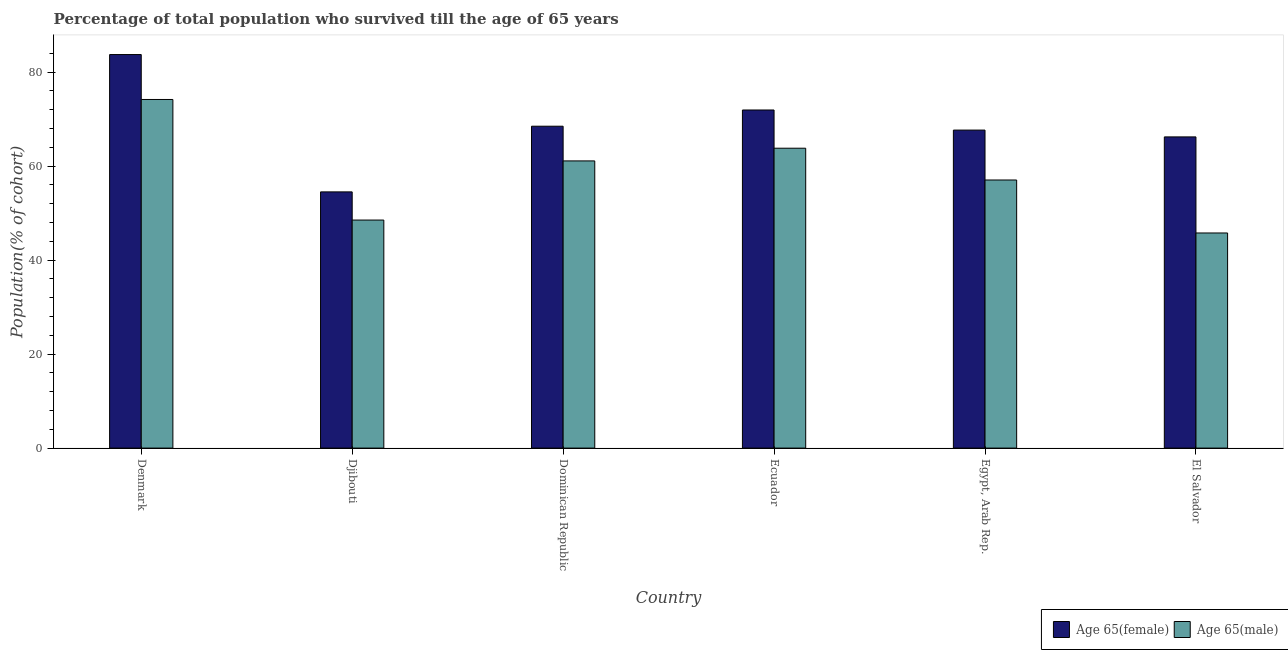Are the number of bars on each tick of the X-axis equal?
Offer a very short reply. Yes. What is the label of the 4th group of bars from the left?
Ensure brevity in your answer.  Ecuador. What is the percentage of male population who survived till age of 65 in Dominican Republic?
Keep it short and to the point. 61.1. Across all countries, what is the maximum percentage of female population who survived till age of 65?
Give a very brief answer. 83.73. Across all countries, what is the minimum percentage of female population who survived till age of 65?
Your answer should be compact. 54.51. In which country was the percentage of female population who survived till age of 65 maximum?
Ensure brevity in your answer.  Denmark. In which country was the percentage of male population who survived till age of 65 minimum?
Your response must be concise. El Salvador. What is the total percentage of female population who survived till age of 65 in the graph?
Make the answer very short. 412.53. What is the difference between the percentage of female population who survived till age of 65 in Denmark and that in Dominican Republic?
Offer a terse response. 15.25. What is the difference between the percentage of male population who survived till age of 65 in Djibouti and the percentage of female population who survived till age of 65 in Egypt, Arab Rep.?
Make the answer very short. -19.14. What is the average percentage of female population who survived till age of 65 per country?
Your answer should be very brief. 68.76. What is the difference between the percentage of male population who survived till age of 65 and percentage of female population who survived till age of 65 in Dominican Republic?
Provide a succinct answer. -7.38. In how many countries, is the percentage of male population who survived till age of 65 greater than 60 %?
Offer a terse response. 3. What is the ratio of the percentage of male population who survived till age of 65 in Dominican Republic to that in Ecuador?
Your answer should be compact. 0.96. Is the percentage of male population who survived till age of 65 in Denmark less than that in Djibouti?
Your response must be concise. No. What is the difference between the highest and the second highest percentage of female population who survived till age of 65?
Make the answer very short. 11.79. What is the difference between the highest and the lowest percentage of male population who survived till age of 65?
Give a very brief answer. 28.4. In how many countries, is the percentage of female population who survived till age of 65 greater than the average percentage of female population who survived till age of 65 taken over all countries?
Your response must be concise. 2. What does the 2nd bar from the left in Ecuador represents?
Your answer should be very brief. Age 65(male). What does the 2nd bar from the right in Denmark represents?
Ensure brevity in your answer.  Age 65(female). How many bars are there?
Offer a terse response. 12. Are all the bars in the graph horizontal?
Ensure brevity in your answer.  No. Are the values on the major ticks of Y-axis written in scientific E-notation?
Make the answer very short. No. Does the graph contain any zero values?
Offer a very short reply. No. Where does the legend appear in the graph?
Provide a short and direct response. Bottom right. How many legend labels are there?
Your answer should be compact. 2. What is the title of the graph?
Ensure brevity in your answer.  Percentage of total population who survived till the age of 65 years. Does "Depositors" appear as one of the legend labels in the graph?
Provide a short and direct response. No. What is the label or title of the X-axis?
Make the answer very short. Country. What is the label or title of the Y-axis?
Provide a succinct answer. Population(% of cohort). What is the Population(% of cohort) in Age 65(female) in Denmark?
Give a very brief answer. 83.73. What is the Population(% of cohort) in Age 65(male) in Denmark?
Your response must be concise. 74.17. What is the Population(% of cohort) of Age 65(female) in Djibouti?
Keep it short and to the point. 54.51. What is the Population(% of cohort) in Age 65(male) in Djibouti?
Provide a short and direct response. 48.52. What is the Population(% of cohort) in Age 65(female) in Dominican Republic?
Provide a succinct answer. 68.48. What is the Population(% of cohort) of Age 65(male) in Dominican Republic?
Offer a very short reply. 61.1. What is the Population(% of cohort) in Age 65(female) in Ecuador?
Give a very brief answer. 71.94. What is the Population(% of cohort) in Age 65(male) in Ecuador?
Provide a succinct answer. 63.81. What is the Population(% of cohort) in Age 65(female) in Egypt, Arab Rep.?
Keep it short and to the point. 67.66. What is the Population(% of cohort) in Age 65(male) in Egypt, Arab Rep.?
Make the answer very short. 57.04. What is the Population(% of cohort) of Age 65(female) in El Salvador?
Offer a very short reply. 66.21. What is the Population(% of cohort) in Age 65(male) in El Salvador?
Your response must be concise. 45.77. Across all countries, what is the maximum Population(% of cohort) in Age 65(female)?
Make the answer very short. 83.73. Across all countries, what is the maximum Population(% of cohort) of Age 65(male)?
Your response must be concise. 74.17. Across all countries, what is the minimum Population(% of cohort) of Age 65(female)?
Give a very brief answer. 54.51. Across all countries, what is the minimum Population(% of cohort) of Age 65(male)?
Ensure brevity in your answer.  45.77. What is the total Population(% of cohort) of Age 65(female) in the graph?
Give a very brief answer. 412.53. What is the total Population(% of cohort) in Age 65(male) in the graph?
Offer a terse response. 350.41. What is the difference between the Population(% of cohort) in Age 65(female) in Denmark and that in Djibouti?
Provide a succinct answer. 29.22. What is the difference between the Population(% of cohort) in Age 65(male) in Denmark and that in Djibouti?
Offer a terse response. 25.65. What is the difference between the Population(% of cohort) in Age 65(female) in Denmark and that in Dominican Republic?
Keep it short and to the point. 15.25. What is the difference between the Population(% of cohort) of Age 65(male) in Denmark and that in Dominican Republic?
Your response must be concise. 13.07. What is the difference between the Population(% of cohort) of Age 65(female) in Denmark and that in Ecuador?
Give a very brief answer. 11.79. What is the difference between the Population(% of cohort) of Age 65(male) in Denmark and that in Ecuador?
Your answer should be compact. 10.37. What is the difference between the Population(% of cohort) in Age 65(female) in Denmark and that in Egypt, Arab Rep.?
Provide a succinct answer. 16.07. What is the difference between the Population(% of cohort) of Age 65(male) in Denmark and that in Egypt, Arab Rep.?
Ensure brevity in your answer.  17.13. What is the difference between the Population(% of cohort) of Age 65(female) in Denmark and that in El Salvador?
Provide a succinct answer. 17.52. What is the difference between the Population(% of cohort) of Age 65(male) in Denmark and that in El Salvador?
Your answer should be very brief. 28.4. What is the difference between the Population(% of cohort) of Age 65(female) in Djibouti and that in Dominican Republic?
Your answer should be very brief. -13.97. What is the difference between the Population(% of cohort) of Age 65(male) in Djibouti and that in Dominican Republic?
Your answer should be very brief. -12.58. What is the difference between the Population(% of cohort) of Age 65(female) in Djibouti and that in Ecuador?
Ensure brevity in your answer.  -17.43. What is the difference between the Population(% of cohort) in Age 65(male) in Djibouti and that in Ecuador?
Offer a terse response. -15.29. What is the difference between the Population(% of cohort) in Age 65(female) in Djibouti and that in Egypt, Arab Rep.?
Give a very brief answer. -13.15. What is the difference between the Population(% of cohort) in Age 65(male) in Djibouti and that in Egypt, Arab Rep.?
Your response must be concise. -8.52. What is the difference between the Population(% of cohort) of Age 65(female) in Djibouti and that in El Salvador?
Offer a very short reply. -11.7. What is the difference between the Population(% of cohort) in Age 65(male) in Djibouti and that in El Salvador?
Provide a short and direct response. 2.75. What is the difference between the Population(% of cohort) in Age 65(female) in Dominican Republic and that in Ecuador?
Offer a very short reply. -3.45. What is the difference between the Population(% of cohort) of Age 65(male) in Dominican Republic and that in Ecuador?
Give a very brief answer. -2.7. What is the difference between the Population(% of cohort) in Age 65(female) in Dominican Republic and that in Egypt, Arab Rep.?
Your answer should be very brief. 0.83. What is the difference between the Population(% of cohort) in Age 65(male) in Dominican Republic and that in Egypt, Arab Rep.?
Ensure brevity in your answer.  4.06. What is the difference between the Population(% of cohort) in Age 65(female) in Dominican Republic and that in El Salvador?
Give a very brief answer. 2.27. What is the difference between the Population(% of cohort) of Age 65(male) in Dominican Republic and that in El Salvador?
Your answer should be very brief. 15.33. What is the difference between the Population(% of cohort) in Age 65(female) in Ecuador and that in Egypt, Arab Rep.?
Your answer should be very brief. 4.28. What is the difference between the Population(% of cohort) in Age 65(male) in Ecuador and that in Egypt, Arab Rep.?
Provide a short and direct response. 6.76. What is the difference between the Population(% of cohort) of Age 65(female) in Ecuador and that in El Salvador?
Your answer should be compact. 5.73. What is the difference between the Population(% of cohort) of Age 65(male) in Ecuador and that in El Salvador?
Offer a terse response. 18.04. What is the difference between the Population(% of cohort) in Age 65(female) in Egypt, Arab Rep. and that in El Salvador?
Provide a succinct answer. 1.45. What is the difference between the Population(% of cohort) in Age 65(male) in Egypt, Arab Rep. and that in El Salvador?
Provide a short and direct response. 11.27. What is the difference between the Population(% of cohort) of Age 65(female) in Denmark and the Population(% of cohort) of Age 65(male) in Djibouti?
Provide a short and direct response. 35.21. What is the difference between the Population(% of cohort) in Age 65(female) in Denmark and the Population(% of cohort) in Age 65(male) in Dominican Republic?
Your answer should be very brief. 22.63. What is the difference between the Population(% of cohort) of Age 65(female) in Denmark and the Population(% of cohort) of Age 65(male) in Ecuador?
Provide a succinct answer. 19.93. What is the difference between the Population(% of cohort) of Age 65(female) in Denmark and the Population(% of cohort) of Age 65(male) in Egypt, Arab Rep.?
Your answer should be compact. 26.69. What is the difference between the Population(% of cohort) in Age 65(female) in Denmark and the Population(% of cohort) in Age 65(male) in El Salvador?
Keep it short and to the point. 37.96. What is the difference between the Population(% of cohort) of Age 65(female) in Djibouti and the Population(% of cohort) of Age 65(male) in Dominican Republic?
Offer a terse response. -6.59. What is the difference between the Population(% of cohort) of Age 65(female) in Djibouti and the Population(% of cohort) of Age 65(male) in Ecuador?
Provide a short and direct response. -9.29. What is the difference between the Population(% of cohort) in Age 65(female) in Djibouti and the Population(% of cohort) in Age 65(male) in Egypt, Arab Rep.?
Make the answer very short. -2.53. What is the difference between the Population(% of cohort) of Age 65(female) in Djibouti and the Population(% of cohort) of Age 65(male) in El Salvador?
Offer a very short reply. 8.74. What is the difference between the Population(% of cohort) in Age 65(female) in Dominican Republic and the Population(% of cohort) in Age 65(male) in Ecuador?
Your response must be concise. 4.68. What is the difference between the Population(% of cohort) of Age 65(female) in Dominican Republic and the Population(% of cohort) of Age 65(male) in Egypt, Arab Rep.?
Give a very brief answer. 11.44. What is the difference between the Population(% of cohort) in Age 65(female) in Dominican Republic and the Population(% of cohort) in Age 65(male) in El Salvador?
Make the answer very short. 22.72. What is the difference between the Population(% of cohort) in Age 65(female) in Ecuador and the Population(% of cohort) in Age 65(male) in Egypt, Arab Rep.?
Provide a succinct answer. 14.89. What is the difference between the Population(% of cohort) of Age 65(female) in Ecuador and the Population(% of cohort) of Age 65(male) in El Salvador?
Keep it short and to the point. 26.17. What is the difference between the Population(% of cohort) in Age 65(female) in Egypt, Arab Rep. and the Population(% of cohort) in Age 65(male) in El Salvador?
Your answer should be compact. 21.89. What is the average Population(% of cohort) of Age 65(female) per country?
Give a very brief answer. 68.76. What is the average Population(% of cohort) in Age 65(male) per country?
Make the answer very short. 58.4. What is the difference between the Population(% of cohort) of Age 65(female) and Population(% of cohort) of Age 65(male) in Denmark?
Provide a short and direct response. 9.56. What is the difference between the Population(% of cohort) in Age 65(female) and Population(% of cohort) in Age 65(male) in Djibouti?
Offer a very short reply. 5.99. What is the difference between the Population(% of cohort) in Age 65(female) and Population(% of cohort) in Age 65(male) in Dominican Republic?
Your answer should be compact. 7.38. What is the difference between the Population(% of cohort) of Age 65(female) and Population(% of cohort) of Age 65(male) in Ecuador?
Offer a terse response. 8.13. What is the difference between the Population(% of cohort) of Age 65(female) and Population(% of cohort) of Age 65(male) in Egypt, Arab Rep.?
Your answer should be very brief. 10.62. What is the difference between the Population(% of cohort) in Age 65(female) and Population(% of cohort) in Age 65(male) in El Salvador?
Make the answer very short. 20.44. What is the ratio of the Population(% of cohort) in Age 65(female) in Denmark to that in Djibouti?
Your answer should be very brief. 1.54. What is the ratio of the Population(% of cohort) of Age 65(male) in Denmark to that in Djibouti?
Your answer should be compact. 1.53. What is the ratio of the Population(% of cohort) in Age 65(female) in Denmark to that in Dominican Republic?
Your answer should be compact. 1.22. What is the ratio of the Population(% of cohort) of Age 65(male) in Denmark to that in Dominican Republic?
Provide a short and direct response. 1.21. What is the ratio of the Population(% of cohort) in Age 65(female) in Denmark to that in Ecuador?
Provide a short and direct response. 1.16. What is the ratio of the Population(% of cohort) of Age 65(male) in Denmark to that in Ecuador?
Your answer should be compact. 1.16. What is the ratio of the Population(% of cohort) in Age 65(female) in Denmark to that in Egypt, Arab Rep.?
Give a very brief answer. 1.24. What is the ratio of the Population(% of cohort) in Age 65(male) in Denmark to that in Egypt, Arab Rep.?
Offer a terse response. 1.3. What is the ratio of the Population(% of cohort) in Age 65(female) in Denmark to that in El Salvador?
Keep it short and to the point. 1.26. What is the ratio of the Population(% of cohort) in Age 65(male) in Denmark to that in El Salvador?
Keep it short and to the point. 1.62. What is the ratio of the Population(% of cohort) of Age 65(female) in Djibouti to that in Dominican Republic?
Make the answer very short. 0.8. What is the ratio of the Population(% of cohort) in Age 65(male) in Djibouti to that in Dominican Republic?
Your response must be concise. 0.79. What is the ratio of the Population(% of cohort) of Age 65(female) in Djibouti to that in Ecuador?
Keep it short and to the point. 0.76. What is the ratio of the Population(% of cohort) in Age 65(male) in Djibouti to that in Ecuador?
Your answer should be compact. 0.76. What is the ratio of the Population(% of cohort) of Age 65(female) in Djibouti to that in Egypt, Arab Rep.?
Keep it short and to the point. 0.81. What is the ratio of the Population(% of cohort) in Age 65(male) in Djibouti to that in Egypt, Arab Rep.?
Keep it short and to the point. 0.85. What is the ratio of the Population(% of cohort) of Age 65(female) in Djibouti to that in El Salvador?
Give a very brief answer. 0.82. What is the ratio of the Population(% of cohort) in Age 65(male) in Djibouti to that in El Salvador?
Ensure brevity in your answer.  1.06. What is the ratio of the Population(% of cohort) in Age 65(male) in Dominican Republic to that in Ecuador?
Offer a very short reply. 0.96. What is the ratio of the Population(% of cohort) in Age 65(female) in Dominican Republic to that in Egypt, Arab Rep.?
Give a very brief answer. 1.01. What is the ratio of the Population(% of cohort) in Age 65(male) in Dominican Republic to that in Egypt, Arab Rep.?
Ensure brevity in your answer.  1.07. What is the ratio of the Population(% of cohort) in Age 65(female) in Dominican Republic to that in El Salvador?
Your answer should be very brief. 1.03. What is the ratio of the Population(% of cohort) in Age 65(male) in Dominican Republic to that in El Salvador?
Offer a very short reply. 1.33. What is the ratio of the Population(% of cohort) of Age 65(female) in Ecuador to that in Egypt, Arab Rep.?
Offer a terse response. 1.06. What is the ratio of the Population(% of cohort) in Age 65(male) in Ecuador to that in Egypt, Arab Rep.?
Give a very brief answer. 1.12. What is the ratio of the Population(% of cohort) of Age 65(female) in Ecuador to that in El Salvador?
Keep it short and to the point. 1.09. What is the ratio of the Population(% of cohort) in Age 65(male) in Ecuador to that in El Salvador?
Your response must be concise. 1.39. What is the ratio of the Population(% of cohort) of Age 65(female) in Egypt, Arab Rep. to that in El Salvador?
Make the answer very short. 1.02. What is the ratio of the Population(% of cohort) in Age 65(male) in Egypt, Arab Rep. to that in El Salvador?
Provide a short and direct response. 1.25. What is the difference between the highest and the second highest Population(% of cohort) in Age 65(female)?
Ensure brevity in your answer.  11.79. What is the difference between the highest and the second highest Population(% of cohort) of Age 65(male)?
Your response must be concise. 10.37. What is the difference between the highest and the lowest Population(% of cohort) in Age 65(female)?
Your response must be concise. 29.22. What is the difference between the highest and the lowest Population(% of cohort) of Age 65(male)?
Your answer should be very brief. 28.4. 